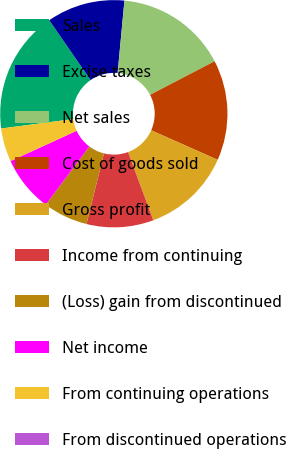Convert chart. <chart><loc_0><loc_0><loc_500><loc_500><pie_chart><fcel>Sales<fcel>Excise taxes<fcel>Net sales<fcel>Cost of goods sold<fcel>Gross profit<fcel>Income from continuing<fcel>(Loss) gain from discontinued<fcel>Net income<fcel>From continuing operations<fcel>From discontinued operations<nl><fcel>17.46%<fcel>11.11%<fcel>15.87%<fcel>14.29%<fcel>12.7%<fcel>9.52%<fcel>6.35%<fcel>7.94%<fcel>4.76%<fcel>0.0%<nl></chart> 